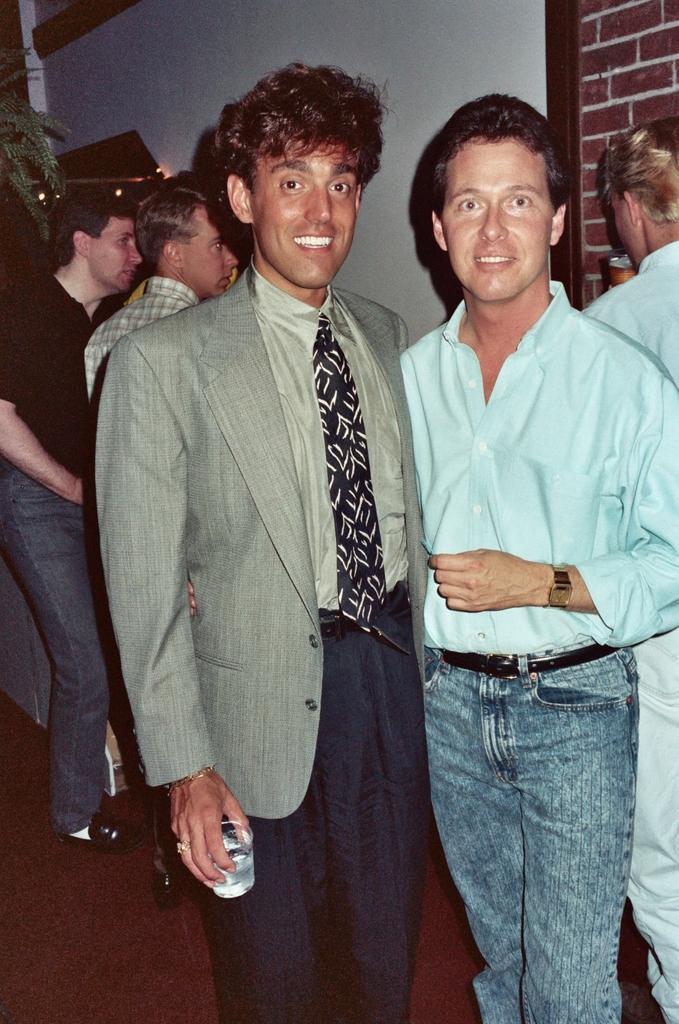Can you describe this image briefly? In this image we can see a few people, one of them is holding a glass, another person is drinking, also we can see the plant, and the wall. 